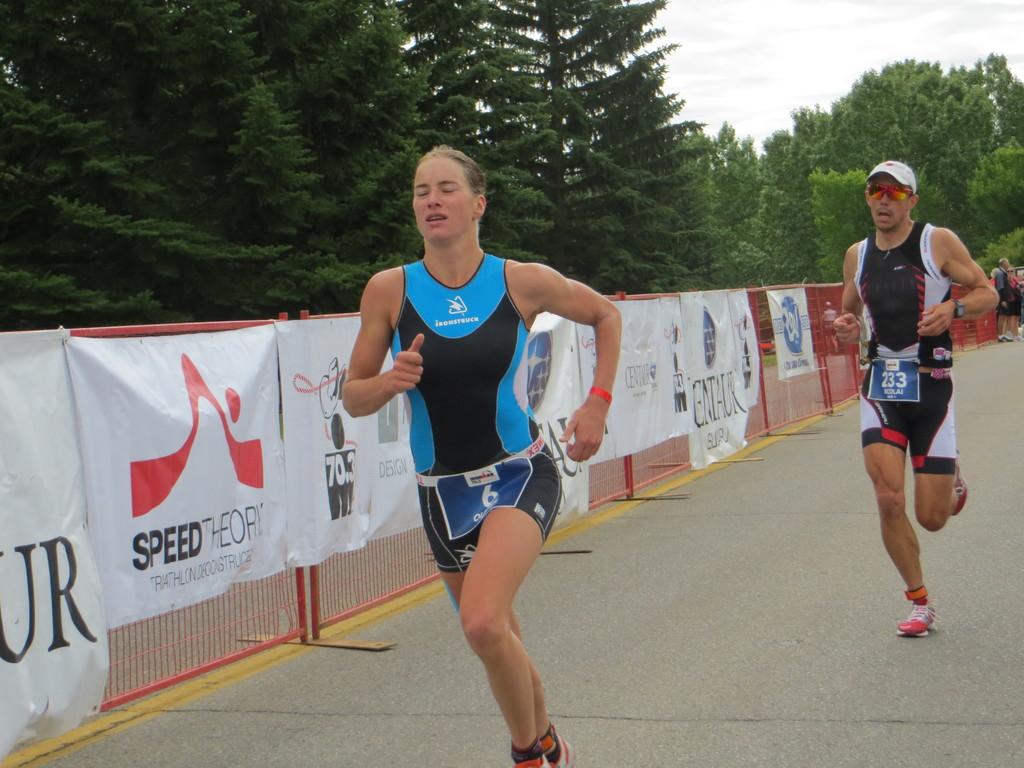What number is the girl in first place?
Your response must be concise. 6. What number is the guy in back?
Make the answer very short. 233. 